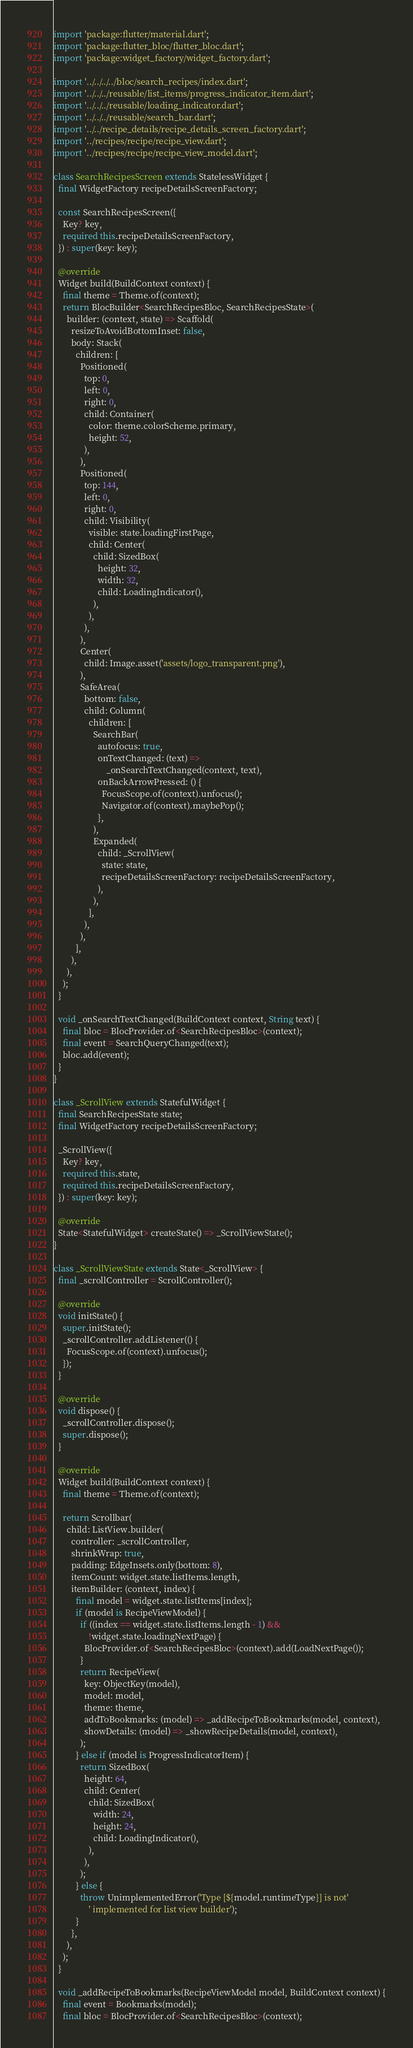Convert code to text. <code><loc_0><loc_0><loc_500><loc_500><_Dart_>import 'package:flutter/material.dart';
import 'package:flutter_bloc/flutter_bloc.dart';
import 'package:widget_factory/widget_factory.dart';

import '../../../../bloc/search_recipes/index.dart';
import '../../../reusable/list_items/progress_indicator_item.dart';
import '../../../reusable/loading_indicator.dart';
import '../../../reusable/search_bar.dart';
import '../../recipe_details/recipe_details_screen_factory.dart';
import '../recipes/recipe/recipe_view.dart';
import '../recipes/recipe/recipe_view_model.dart';

class SearchRecipesScreen extends StatelessWidget {
  final WidgetFactory recipeDetailsScreenFactory;

  const SearchRecipesScreen({
    Key? key,
    required this.recipeDetailsScreenFactory,
  }) : super(key: key);

  @override
  Widget build(BuildContext context) {
    final theme = Theme.of(context);
    return BlocBuilder<SearchRecipesBloc, SearchRecipesState>(
      builder: (context, state) => Scaffold(
        resizeToAvoidBottomInset: false,
        body: Stack(
          children: [
            Positioned(
              top: 0,
              left: 0,
              right: 0,
              child: Container(
                color: theme.colorScheme.primary,
                height: 52,
              ),
            ),
            Positioned(
              top: 144,
              left: 0,
              right: 0,
              child: Visibility(
                visible: state.loadingFirstPage,
                child: Center(
                  child: SizedBox(
                    height: 32,
                    width: 32,
                    child: LoadingIndicator(),
                  ),
                ),
              ),
            ),
            Center(
              child: Image.asset('assets/logo_transparent.png'),
            ),
            SafeArea(
              bottom: false,
              child: Column(
                children: [
                  SearchBar(
                    autofocus: true,
                    onTextChanged: (text) =>
                        _onSearchTextChanged(context, text),
                    onBackArrowPressed: () {
                      FocusScope.of(context).unfocus();
                      Navigator.of(context).maybePop();
                    },
                  ),
                  Expanded(
                    child: _ScrollView(
                      state: state,
                      recipeDetailsScreenFactory: recipeDetailsScreenFactory,
                    ),
                  ),
                ],
              ),
            ),
          ],
        ),
      ),
    );
  }

  void _onSearchTextChanged(BuildContext context, String text) {
    final bloc = BlocProvider.of<SearchRecipesBloc>(context);
    final event = SearchQueryChanged(text);
    bloc.add(event);
  }
}

class _ScrollView extends StatefulWidget {
  final SearchRecipesState state;
  final WidgetFactory recipeDetailsScreenFactory;

  _ScrollView({
    Key? key,
    required this.state,
    required this.recipeDetailsScreenFactory,
  }) : super(key: key);

  @override
  State<StatefulWidget> createState() => _ScrollViewState();
}

class _ScrollViewState extends State<_ScrollView> {
  final _scrollController = ScrollController();

  @override
  void initState() {
    super.initState();
    _scrollController.addListener(() {
      FocusScope.of(context).unfocus();
    });
  }

  @override
  void dispose() {
    _scrollController.dispose();
    super.dispose();
  }

  @override
  Widget build(BuildContext context) {
    final theme = Theme.of(context);

    return Scrollbar(
      child: ListView.builder(
        controller: _scrollController,
        shrinkWrap: true,
        padding: EdgeInsets.only(bottom: 8),
        itemCount: widget.state.listItems.length,
        itemBuilder: (context, index) {
          final model = widget.state.listItems[index];
          if (model is RecipeViewModel) {
            if ((index == widget.state.listItems.length - 1) &&
                !widget.state.loadingNextPage) {
              BlocProvider.of<SearchRecipesBloc>(context).add(LoadNextPage());
            }
            return RecipeView(
              key: ObjectKey(model),
              model: model,
              theme: theme,
              addToBookmarks: (model) => _addRecipeToBookmarks(model, context),
              showDetails: (model) => _showRecipeDetails(model, context),
            );
          } else if (model is ProgressIndicatorItem) {
            return SizedBox(
              height: 64,
              child: Center(
                child: SizedBox(
                  width: 24,
                  height: 24,
                  child: LoadingIndicator(),
                ),
              ),
            );
          } else {
            throw UnimplementedError('Type [${model.runtimeType}] is not'
                ' implemented for list view builder');
          }
        },
      ),
    );
  }

  void _addRecipeToBookmarks(RecipeViewModel model, BuildContext context) {
    final event = Bookmarks(model);
    final bloc = BlocProvider.of<SearchRecipesBloc>(context);</code> 